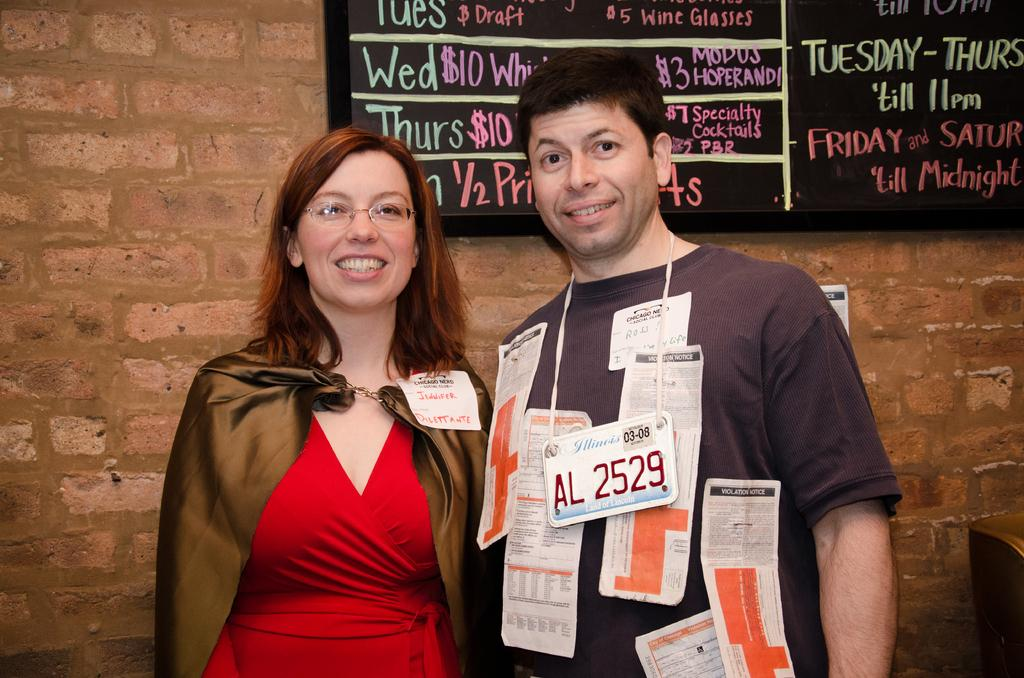How many people are in the image? There are two persons in the image. What are the persons doing in the image? The persons are standing. What can be seen on the persons in the image? The persons have tags and papers. What is the facial expression of the persons in the image? The persons are smiling. What is visible in the background of the image? There is: There is a board attached to the wall in the background of the image. Can you tell me how the persons are pushing the structure in the image? There is no structure present in the image for the persons to push. How do the persons fly in the image? The persons are not flying in the image; they are standing on the ground. 